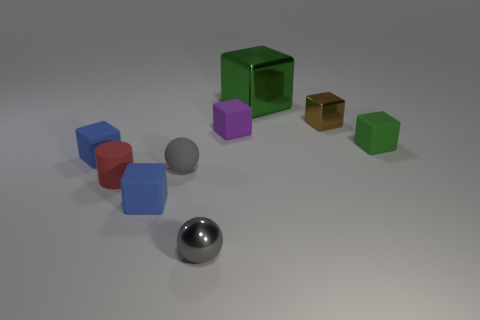Subtract all small blue cubes. How many cubes are left? 4 Subtract all yellow cylinders. How many green cubes are left? 2 Subtract 1 blocks. How many blocks are left? 5 Subtract all purple cubes. How many cubes are left? 5 Add 1 metallic cubes. How many objects exist? 10 Subtract all blue blocks. Subtract all red cylinders. How many blocks are left? 4 Subtract all cylinders. How many objects are left? 8 Subtract all small brown metal cylinders. Subtract all metal things. How many objects are left? 6 Add 9 rubber balls. How many rubber balls are left? 10 Add 2 tiny red matte cylinders. How many tiny red matte cylinders exist? 3 